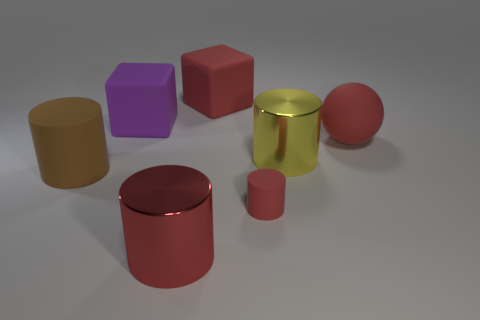What could this arrangement of shapes be used for? This setup of shapes might be part of a visualization task in cognitive or educational studies, perhaps to assess spatial reasoning or to provide a learning exercise for geometry students, demonstrating various properties such as reflection, texture, and spatial positioning. How might the colors of the objects play a role in such studies? The distinct colors of the objects could help in differentiating them while also possibly being used to assess color recognition or to create associations with specific geometric concepts. In educational settings, this color-coding can aid in engaging learners and reinforcing memory retention. 